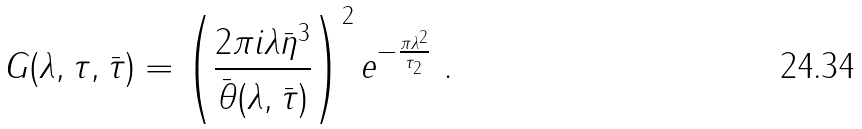Convert formula to latex. <formula><loc_0><loc_0><loc_500><loc_500>G ( \lambda , \tau , \bar { \tau } ) = \left ( \frac { 2 \pi i \lambda \bar { \eta } ^ { 3 } } { \bar { \theta } ( \lambda , \bar { \tau } ) } \right ) ^ { 2 } e ^ { - \frac { \pi \lambda ^ { 2 } } { \tau _ { 2 } } } \ .</formula> 